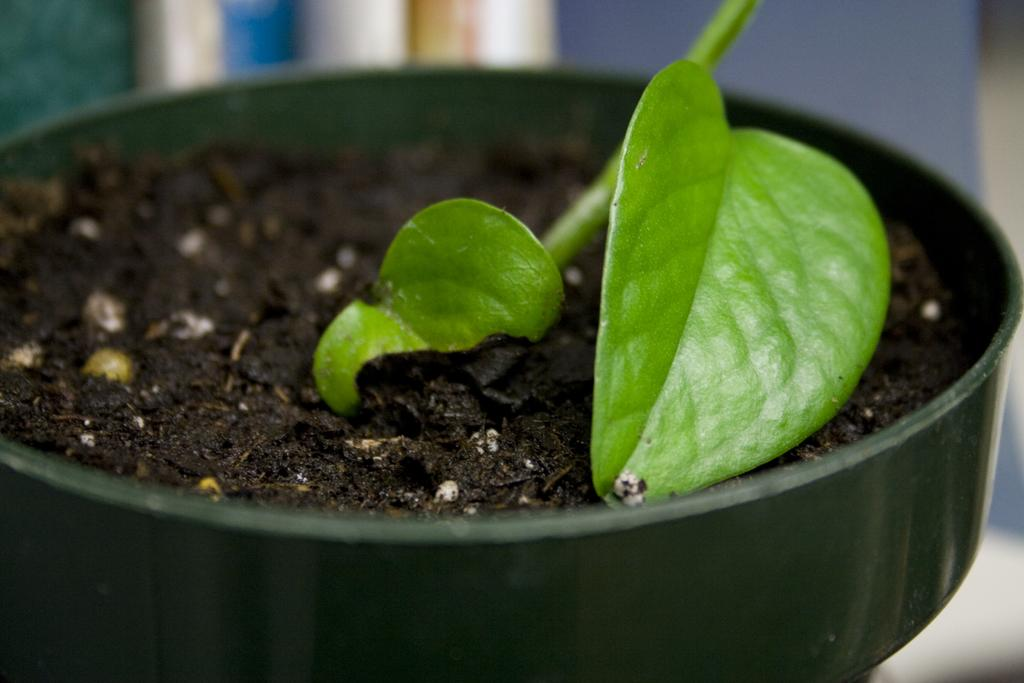What is located in the foreground of the image? There is a flower pot in the foreground of the image. What is inside the flower pot? There is a plant and mud in the flower pot. How would you describe the background of the image? The background of the image is blurred. Can you see any cracks in the vessel holding the plant in the image? There is no vessel mentioned in the facts, only a flower pot. Additionally, there is no mention of any cracks in the flower pot. 